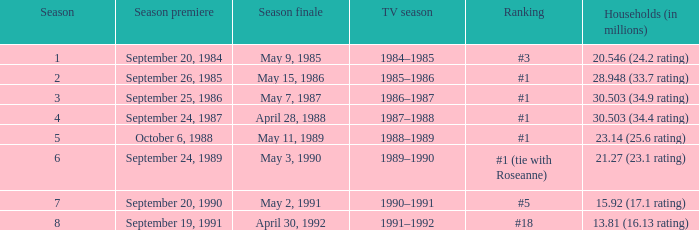Which TV season has a Season larger than 2, and a Ranking of #5? 1990–1991. 